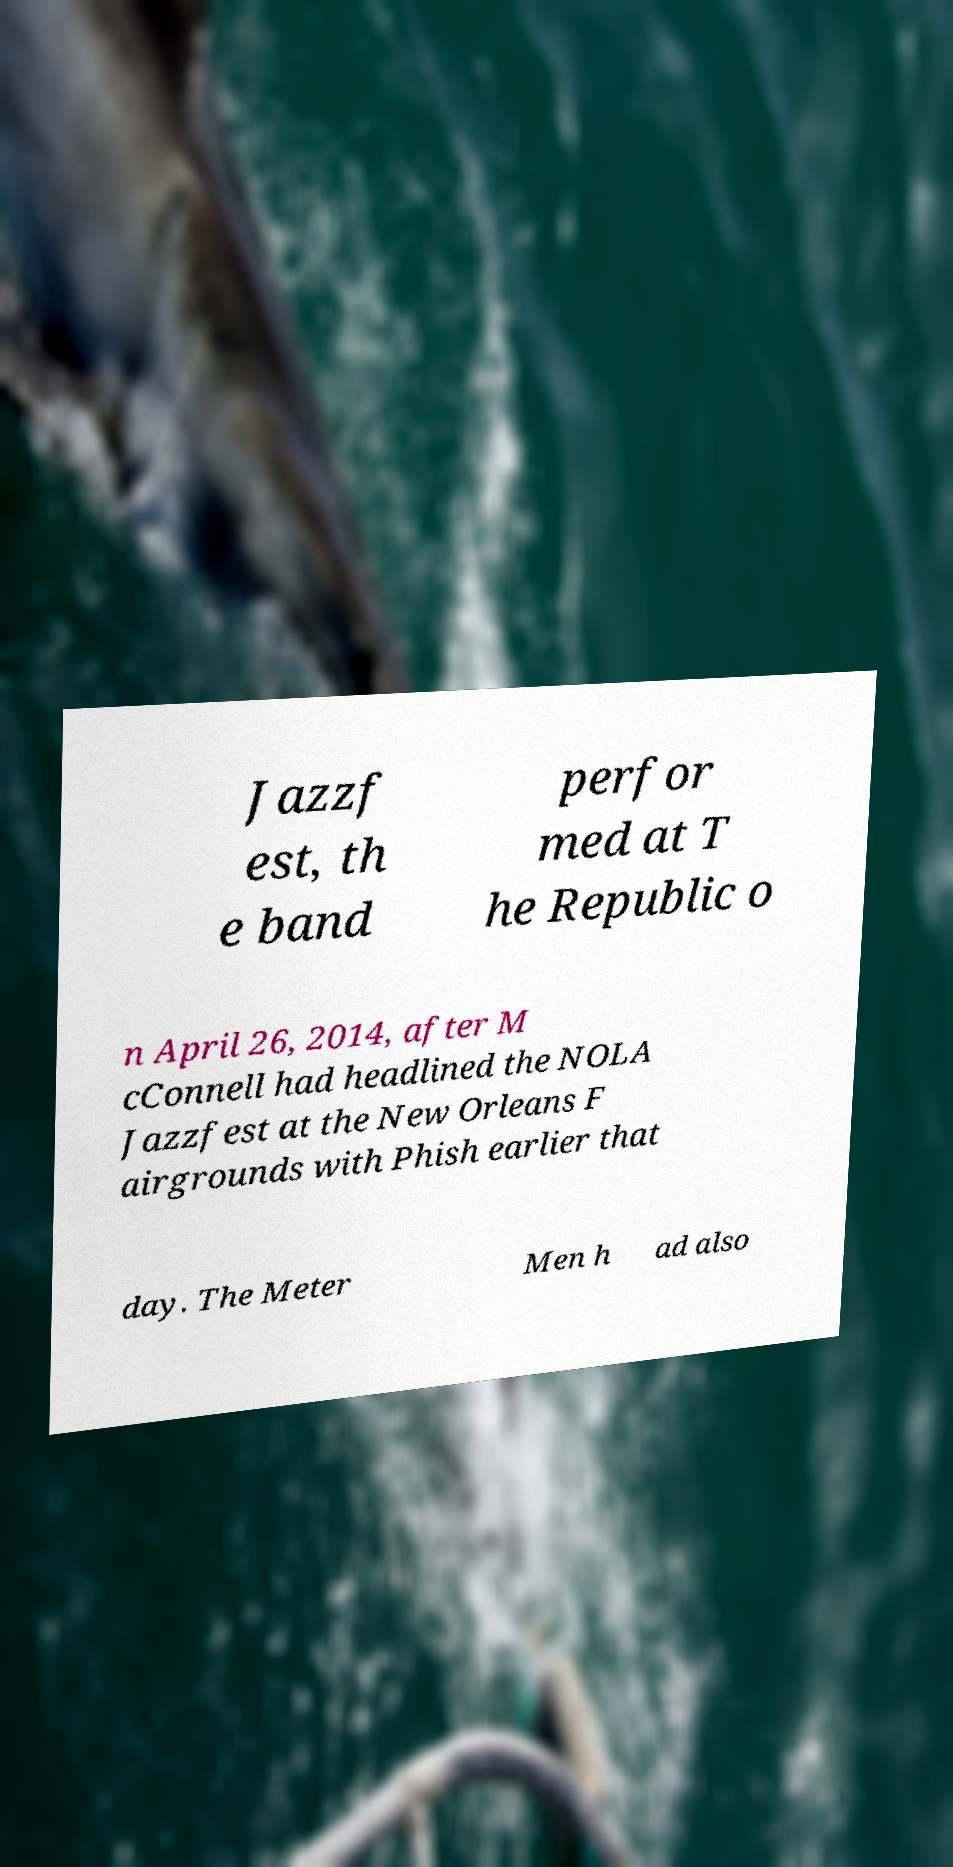There's text embedded in this image that I need extracted. Can you transcribe it verbatim? Jazzf est, th e band perfor med at T he Republic o n April 26, 2014, after M cConnell had headlined the NOLA Jazzfest at the New Orleans F airgrounds with Phish earlier that day. The Meter Men h ad also 